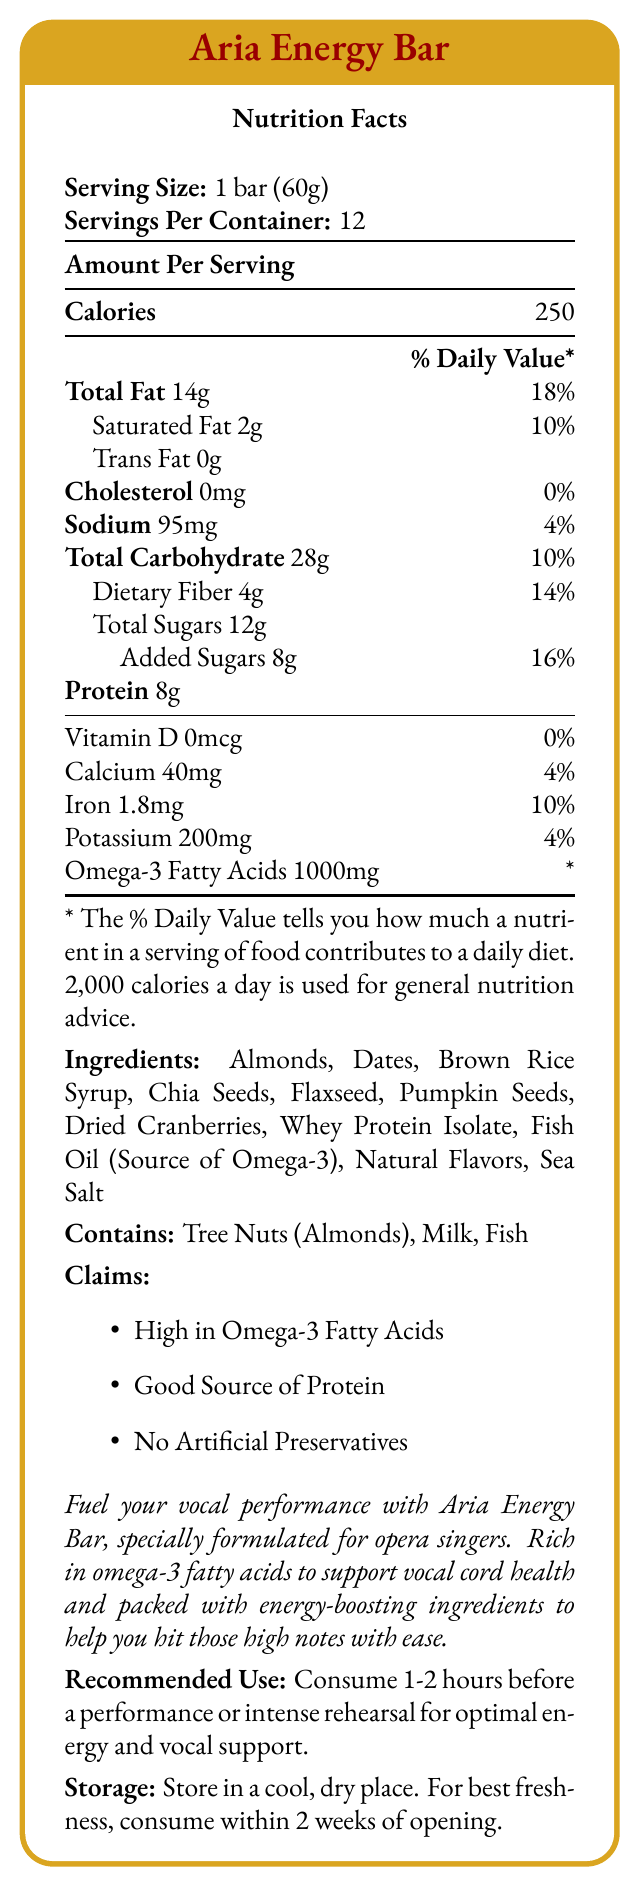what is the serving size of Aria Energy Bar? The serving size is explicitly mentioned at the beginning of the Nutrition Facts section.
Answer: 1 bar (60g) how many calories are in one serving of Aria Energy Bar? The amount of calories per serving is listed under the header "Amount Per Serving".
Answer: 250 how much protein does one bar contain? The protein content per serving is mentioned directly in the nutrition facts.
Answer: 8g what is the daily value percentage for total fat? The document states that the total fat content is 14g and its daily value percentage is 18%.
Answer: 18% how much omega-3 fatty acids are in each serving? The document lists 1000mg of omega-3 fatty acids per serving.
Answer: 1000mg which of the following ingredients is the source of omega-3? A. Chia Seeds B. Fish Oil C. Flaxseed The document specifies that Fish Oil is the source of Omega-3.
Answer: B what are the sources of protein in the Aria Energy Bar? A. Dates and Almonds B. Whey Protein Isolate and Pumpkin Seeds C. Almonds and Chia Seeds The document lists Whey Protein Isolate, which is a known protein source, and pumpkin seeds which also contribute to protein content.
Answer: B does the Aria Energy Bar contain any artificial preservatives? The document claims that the bar has "No Artificial Preservatives".
Answer: No is the Aria Energy Bar suitable for someone with a tree nut allergy? The allergen information states that the bar contains Tree Nuts (Almonds).
Answer: No what is the recommended use for Aria Energy Bar? The recommended use is mentioned towards the end of the document.
Answer: Consume 1-2 hours before a performance or intense rehearsal for optimal energy and vocal support. what percentage of the daily value for iron does one bar provide? The document states that the bar provides 1.8mg of iron, which corresponds to 10% of the daily value.
Answer: 10% how many servings are there in one container of Aria Energy Bar? The document states that there are 12 servings per container.
Answer: 12 does the Aria Energy Bar contain any dietary fiber? If so, how much? The document shows that it contains 4g of dietary fiber per serving.
Answer: Yes, 4g summarize the main idea of the document. The summary captures the key highlights and main purpose of the Aria Energy Bar as described in the document.
Answer: The Aria Energy Bar is an omega-3 rich energy bar specifically formulated for opera singers. It contains ingredients that support vocal health and provide energy for performances. Key nutritional facts include 250 calories, 14g of total fat, 8g of protein, and 1000mg of omega-3 fatty acids per serving. It claims to be high in omega-3 fatty acids, a good source of protein, and free from artificial preservatives. what is the maximum duration one should consume the bar after opening for best freshness? The document recommends consuming the bar within 2 weeks of opening for best freshness.
Answer: 2 weeks are there any trans fats in the Aria Energy Bar? The document lists the trans fat content as 0g.
Answer: No where should the Aria Energy Bar be stored? The document specifies to store the bar in a cool, dry place.
Answer: In a cool, dry place how much sugar is in one serving, and is there a distinction between total sugars and added sugars? The document indicates that out of 12g of total sugars, 8g are added sugars.
Answer: 12g total sugars, 8g added sugars does the serving size relate to the entire container or just one bar? The serving size of 1 bar (60g) refers to an individual serving, not the entire container.
Answer: Just one bar are there any potential allergens in the Aria Energy Bar? The allergen information indicates the bar contains Tree Nuts (Almonds), Milk, and Fish.
Answer: Yes is it possible to confirm the origin of the omega-3 fatty acids? The document lists Fish Oil as the source of omega-3 fatty acids.
Answer: Yes, from Fish Oil how much calcium is in one serving of Aria Energy Bar? The document lists the calcium content per serving as 40mg.
Answer: 40mg is the nutritional information based on a 2,000-calorie diet? The document mentions that the % Daily Value is based on a 2,000-calorie diet.
Answer: Yes how many calories from fat are there in one serving? The document does not provide a breakdown of the calorie content specifically from fat.
Answer: Not enough information what is the main benefit of omega-3 fatty acids mentioned in the document? The marketing description mentions that omega-3 fatty acids help support vocal cord health.
Answer: To support vocal cord health 